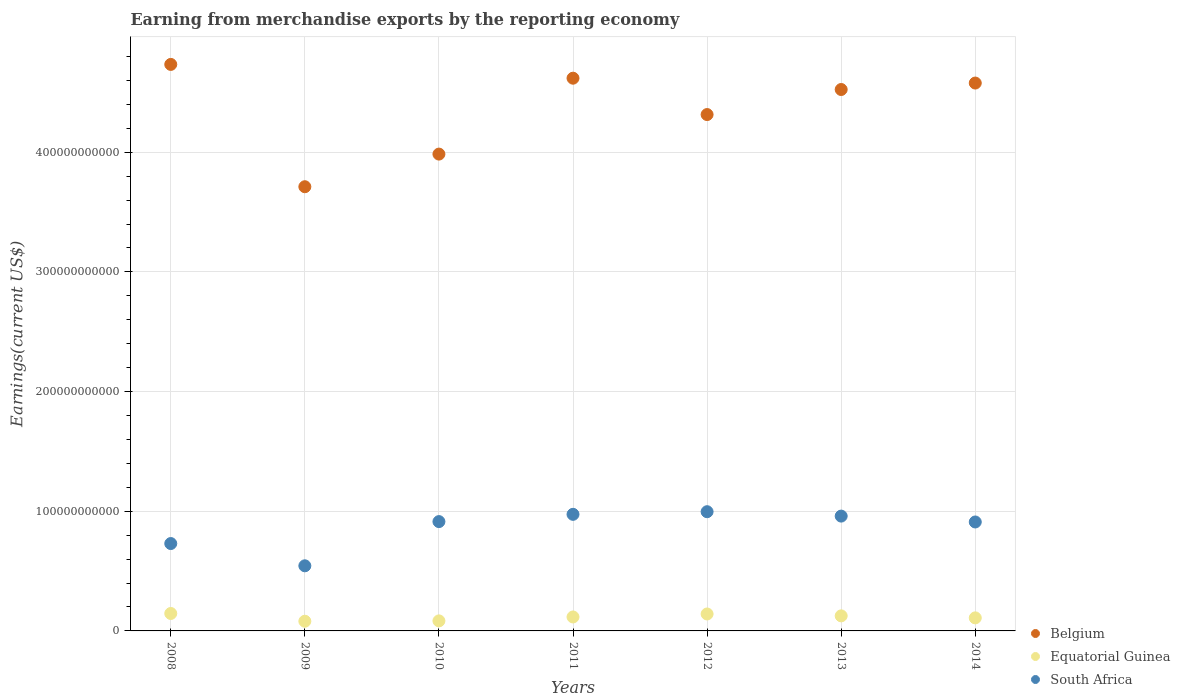How many different coloured dotlines are there?
Keep it short and to the point. 3. Is the number of dotlines equal to the number of legend labels?
Make the answer very short. Yes. What is the amount earned from merchandise exports in South Africa in 2013?
Your response must be concise. 9.59e+1. Across all years, what is the maximum amount earned from merchandise exports in Belgium?
Your answer should be very brief. 4.73e+11. Across all years, what is the minimum amount earned from merchandise exports in Equatorial Guinea?
Your answer should be compact. 8.09e+09. What is the total amount earned from merchandise exports in South Africa in the graph?
Give a very brief answer. 6.03e+11. What is the difference between the amount earned from merchandise exports in Belgium in 2008 and that in 2013?
Your answer should be very brief. 2.10e+1. What is the difference between the amount earned from merchandise exports in South Africa in 2011 and the amount earned from merchandise exports in Equatorial Guinea in 2012?
Ensure brevity in your answer.  8.33e+1. What is the average amount earned from merchandise exports in Belgium per year?
Give a very brief answer. 4.35e+11. In the year 2008, what is the difference between the amount earned from merchandise exports in South Africa and amount earned from merchandise exports in Equatorial Guinea?
Offer a very short reply. 5.84e+1. What is the ratio of the amount earned from merchandise exports in Belgium in 2009 to that in 2013?
Provide a succinct answer. 0.82. What is the difference between the highest and the second highest amount earned from merchandise exports in Equatorial Guinea?
Your answer should be compact. 4.06e+08. What is the difference between the highest and the lowest amount earned from merchandise exports in Equatorial Guinea?
Your answer should be compact. 6.48e+09. Is the sum of the amount earned from merchandise exports in Equatorial Guinea in 2009 and 2014 greater than the maximum amount earned from merchandise exports in South Africa across all years?
Your answer should be compact. No. Is it the case that in every year, the sum of the amount earned from merchandise exports in Equatorial Guinea and amount earned from merchandise exports in Belgium  is greater than the amount earned from merchandise exports in South Africa?
Give a very brief answer. Yes. Does the amount earned from merchandise exports in South Africa monotonically increase over the years?
Provide a succinct answer. No. Is the amount earned from merchandise exports in Equatorial Guinea strictly greater than the amount earned from merchandise exports in Belgium over the years?
Your answer should be compact. No. Is the amount earned from merchandise exports in Equatorial Guinea strictly less than the amount earned from merchandise exports in Belgium over the years?
Make the answer very short. Yes. How many years are there in the graph?
Your response must be concise. 7. What is the difference between two consecutive major ticks on the Y-axis?
Keep it short and to the point. 1.00e+11. Does the graph contain grids?
Keep it short and to the point. Yes. How are the legend labels stacked?
Your answer should be compact. Vertical. What is the title of the graph?
Your response must be concise. Earning from merchandise exports by the reporting economy. Does "Zimbabwe" appear as one of the legend labels in the graph?
Provide a succinct answer. No. What is the label or title of the Y-axis?
Offer a very short reply. Earnings(current US$). What is the Earnings(current US$) in Belgium in 2008?
Provide a succinct answer. 4.73e+11. What is the Earnings(current US$) in Equatorial Guinea in 2008?
Provide a short and direct response. 1.46e+1. What is the Earnings(current US$) in South Africa in 2008?
Keep it short and to the point. 7.30e+1. What is the Earnings(current US$) in Belgium in 2009?
Keep it short and to the point. 3.71e+11. What is the Earnings(current US$) in Equatorial Guinea in 2009?
Keep it short and to the point. 8.09e+09. What is the Earnings(current US$) in South Africa in 2009?
Your response must be concise. 5.44e+1. What is the Earnings(current US$) in Belgium in 2010?
Your answer should be compact. 3.98e+11. What is the Earnings(current US$) of Equatorial Guinea in 2010?
Keep it short and to the point. 8.39e+09. What is the Earnings(current US$) in South Africa in 2010?
Ensure brevity in your answer.  9.13e+1. What is the Earnings(current US$) in Belgium in 2011?
Ensure brevity in your answer.  4.62e+11. What is the Earnings(current US$) in Equatorial Guinea in 2011?
Your answer should be very brief. 1.17e+1. What is the Earnings(current US$) of South Africa in 2011?
Make the answer very short. 9.74e+1. What is the Earnings(current US$) of Belgium in 2012?
Offer a terse response. 4.31e+11. What is the Earnings(current US$) of Equatorial Guinea in 2012?
Ensure brevity in your answer.  1.42e+1. What is the Earnings(current US$) of South Africa in 2012?
Offer a very short reply. 9.96e+1. What is the Earnings(current US$) in Belgium in 2013?
Your answer should be very brief. 4.52e+11. What is the Earnings(current US$) in Equatorial Guinea in 2013?
Offer a terse response. 1.26e+1. What is the Earnings(current US$) in South Africa in 2013?
Give a very brief answer. 9.59e+1. What is the Earnings(current US$) of Belgium in 2014?
Give a very brief answer. 4.58e+11. What is the Earnings(current US$) of Equatorial Guinea in 2014?
Offer a terse response. 1.09e+1. What is the Earnings(current US$) of South Africa in 2014?
Offer a very short reply. 9.10e+1. Across all years, what is the maximum Earnings(current US$) of Belgium?
Keep it short and to the point. 4.73e+11. Across all years, what is the maximum Earnings(current US$) in Equatorial Guinea?
Offer a very short reply. 1.46e+1. Across all years, what is the maximum Earnings(current US$) of South Africa?
Keep it short and to the point. 9.96e+1. Across all years, what is the minimum Earnings(current US$) of Belgium?
Provide a succinct answer. 3.71e+11. Across all years, what is the minimum Earnings(current US$) in Equatorial Guinea?
Provide a succinct answer. 8.09e+09. Across all years, what is the minimum Earnings(current US$) in South Africa?
Offer a very short reply. 5.44e+1. What is the total Earnings(current US$) of Belgium in the graph?
Provide a succinct answer. 3.05e+12. What is the total Earnings(current US$) of Equatorial Guinea in the graph?
Give a very brief answer. 8.04e+1. What is the total Earnings(current US$) of South Africa in the graph?
Your answer should be very brief. 6.03e+11. What is the difference between the Earnings(current US$) in Belgium in 2008 and that in 2009?
Provide a succinct answer. 1.02e+11. What is the difference between the Earnings(current US$) of Equatorial Guinea in 2008 and that in 2009?
Provide a succinct answer. 6.48e+09. What is the difference between the Earnings(current US$) of South Africa in 2008 and that in 2009?
Your answer should be compact. 1.86e+1. What is the difference between the Earnings(current US$) of Belgium in 2008 and that in 2010?
Make the answer very short. 7.49e+1. What is the difference between the Earnings(current US$) in Equatorial Guinea in 2008 and that in 2010?
Provide a succinct answer. 6.17e+09. What is the difference between the Earnings(current US$) of South Africa in 2008 and that in 2010?
Keep it short and to the point. -1.83e+1. What is the difference between the Earnings(current US$) of Belgium in 2008 and that in 2011?
Provide a succinct answer. 1.15e+1. What is the difference between the Earnings(current US$) in Equatorial Guinea in 2008 and that in 2011?
Make the answer very short. 2.90e+09. What is the difference between the Earnings(current US$) in South Africa in 2008 and that in 2011?
Ensure brevity in your answer.  -2.44e+1. What is the difference between the Earnings(current US$) of Belgium in 2008 and that in 2012?
Offer a terse response. 4.19e+1. What is the difference between the Earnings(current US$) of Equatorial Guinea in 2008 and that in 2012?
Offer a very short reply. 4.06e+08. What is the difference between the Earnings(current US$) in South Africa in 2008 and that in 2012?
Offer a very short reply. -2.66e+1. What is the difference between the Earnings(current US$) in Belgium in 2008 and that in 2013?
Provide a succinct answer. 2.10e+1. What is the difference between the Earnings(current US$) in Equatorial Guinea in 2008 and that in 2013?
Your answer should be very brief. 1.99e+09. What is the difference between the Earnings(current US$) in South Africa in 2008 and that in 2013?
Provide a short and direct response. -2.29e+1. What is the difference between the Earnings(current US$) in Belgium in 2008 and that in 2014?
Give a very brief answer. 1.56e+1. What is the difference between the Earnings(current US$) of Equatorial Guinea in 2008 and that in 2014?
Give a very brief answer. 3.66e+09. What is the difference between the Earnings(current US$) in South Africa in 2008 and that in 2014?
Keep it short and to the point. -1.80e+1. What is the difference between the Earnings(current US$) in Belgium in 2009 and that in 2010?
Give a very brief answer. -2.73e+1. What is the difference between the Earnings(current US$) in Equatorial Guinea in 2009 and that in 2010?
Give a very brief answer. -3.05e+08. What is the difference between the Earnings(current US$) in South Africa in 2009 and that in 2010?
Ensure brevity in your answer.  -3.69e+1. What is the difference between the Earnings(current US$) in Belgium in 2009 and that in 2011?
Make the answer very short. -9.07e+1. What is the difference between the Earnings(current US$) in Equatorial Guinea in 2009 and that in 2011?
Provide a short and direct response. -3.58e+09. What is the difference between the Earnings(current US$) of South Africa in 2009 and that in 2011?
Give a very brief answer. -4.30e+1. What is the difference between the Earnings(current US$) of Belgium in 2009 and that in 2012?
Your response must be concise. -6.03e+1. What is the difference between the Earnings(current US$) of Equatorial Guinea in 2009 and that in 2012?
Offer a very short reply. -6.07e+09. What is the difference between the Earnings(current US$) of South Africa in 2009 and that in 2012?
Offer a terse response. -4.52e+1. What is the difference between the Earnings(current US$) in Belgium in 2009 and that in 2013?
Give a very brief answer. -8.12e+1. What is the difference between the Earnings(current US$) in Equatorial Guinea in 2009 and that in 2013?
Keep it short and to the point. -4.49e+09. What is the difference between the Earnings(current US$) of South Africa in 2009 and that in 2013?
Offer a terse response. -4.15e+1. What is the difference between the Earnings(current US$) in Belgium in 2009 and that in 2014?
Make the answer very short. -8.66e+1. What is the difference between the Earnings(current US$) of Equatorial Guinea in 2009 and that in 2014?
Make the answer very short. -2.82e+09. What is the difference between the Earnings(current US$) of South Africa in 2009 and that in 2014?
Ensure brevity in your answer.  -3.66e+1. What is the difference between the Earnings(current US$) of Belgium in 2010 and that in 2011?
Make the answer very short. -6.34e+1. What is the difference between the Earnings(current US$) of Equatorial Guinea in 2010 and that in 2011?
Your answer should be very brief. -3.27e+09. What is the difference between the Earnings(current US$) in South Africa in 2010 and that in 2011?
Your answer should be compact. -6.07e+09. What is the difference between the Earnings(current US$) in Belgium in 2010 and that in 2012?
Ensure brevity in your answer.  -3.30e+1. What is the difference between the Earnings(current US$) of Equatorial Guinea in 2010 and that in 2012?
Ensure brevity in your answer.  -5.77e+09. What is the difference between the Earnings(current US$) in South Africa in 2010 and that in 2012?
Keep it short and to the point. -8.26e+09. What is the difference between the Earnings(current US$) of Belgium in 2010 and that in 2013?
Offer a terse response. -5.40e+1. What is the difference between the Earnings(current US$) of Equatorial Guinea in 2010 and that in 2013?
Your answer should be very brief. -4.19e+09. What is the difference between the Earnings(current US$) in South Africa in 2010 and that in 2013?
Provide a succinct answer. -4.59e+09. What is the difference between the Earnings(current US$) of Belgium in 2010 and that in 2014?
Provide a succinct answer. -5.94e+1. What is the difference between the Earnings(current US$) of Equatorial Guinea in 2010 and that in 2014?
Provide a succinct answer. -2.51e+09. What is the difference between the Earnings(current US$) in South Africa in 2010 and that in 2014?
Your answer should be compact. 3.21e+08. What is the difference between the Earnings(current US$) of Belgium in 2011 and that in 2012?
Provide a succinct answer. 3.04e+1. What is the difference between the Earnings(current US$) in Equatorial Guinea in 2011 and that in 2012?
Provide a succinct answer. -2.50e+09. What is the difference between the Earnings(current US$) in South Africa in 2011 and that in 2012?
Provide a short and direct response. -2.20e+09. What is the difference between the Earnings(current US$) of Belgium in 2011 and that in 2013?
Ensure brevity in your answer.  9.45e+09. What is the difference between the Earnings(current US$) in Equatorial Guinea in 2011 and that in 2013?
Provide a succinct answer. -9.15e+08. What is the difference between the Earnings(current US$) of South Africa in 2011 and that in 2013?
Keep it short and to the point. 1.48e+09. What is the difference between the Earnings(current US$) of Belgium in 2011 and that in 2014?
Your answer should be compact. 4.06e+09. What is the difference between the Earnings(current US$) in Equatorial Guinea in 2011 and that in 2014?
Your response must be concise. 7.57e+08. What is the difference between the Earnings(current US$) of South Africa in 2011 and that in 2014?
Your answer should be compact. 6.39e+09. What is the difference between the Earnings(current US$) of Belgium in 2012 and that in 2013?
Your response must be concise. -2.09e+1. What is the difference between the Earnings(current US$) in Equatorial Guinea in 2012 and that in 2013?
Provide a short and direct response. 1.58e+09. What is the difference between the Earnings(current US$) in South Africa in 2012 and that in 2013?
Make the answer very short. 3.67e+09. What is the difference between the Earnings(current US$) in Belgium in 2012 and that in 2014?
Your response must be concise. -2.63e+1. What is the difference between the Earnings(current US$) in Equatorial Guinea in 2012 and that in 2014?
Make the answer very short. 3.26e+09. What is the difference between the Earnings(current US$) of South Africa in 2012 and that in 2014?
Keep it short and to the point. 8.58e+09. What is the difference between the Earnings(current US$) in Belgium in 2013 and that in 2014?
Keep it short and to the point. -5.39e+09. What is the difference between the Earnings(current US$) in Equatorial Guinea in 2013 and that in 2014?
Make the answer very short. 1.67e+09. What is the difference between the Earnings(current US$) of South Africa in 2013 and that in 2014?
Your answer should be compact. 4.91e+09. What is the difference between the Earnings(current US$) of Belgium in 2008 and the Earnings(current US$) of Equatorial Guinea in 2009?
Ensure brevity in your answer.  4.65e+11. What is the difference between the Earnings(current US$) in Belgium in 2008 and the Earnings(current US$) in South Africa in 2009?
Make the answer very short. 4.19e+11. What is the difference between the Earnings(current US$) of Equatorial Guinea in 2008 and the Earnings(current US$) of South Africa in 2009?
Keep it short and to the point. -3.98e+1. What is the difference between the Earnings(current US$) of Belgium in 2008 and the Earnings(current US$) of Equatorial Guinea in 2010?
Provide a short and direct response. 4.65e+11. What is the difference between the Earnings(current US$) of Belgium in 2008 and the Earnings(current US$) of South Africa in 2010?
Your response must be concise. 3.82e+11. What is the difference between the Earnings(current US$) in Equatorial Guinea in 2008 and the Earnings(current US$) in South Africa in 2010?
Make the answer very short. -7.68e+1. What is the difference between the Earnings(current US$) of Belgium in 2008 and the Earnings(current US$) of Equatorial Guinea in 2011?
Ensure brevity in your answer.  4.62e+11. What is the difference between the Earnings(current US$) of Belgium in 2008 and the Earnings(current US$) of South Africa in 2011?
Offer a terse response. 3.76e+11. What is the difference between the Earnings(current US$) in Equatorial Guinea in 2008 and the Earnings(current US$) in South Africa in 2011?
Provide a short and direct response. -8.28e+1. What is the difference between the Earnings(current US$) of Belgium in 2008 and the Earnings(current US$) of Equatorial Guinea in 2012?
Offer a very short reply. 4.59e+11. What is the difference between the Earnings(current US$) of Belgium in 2008 and the Earnings(current US$) of South Africa in 2012?
Offer a terse response. 3.74e+11. What is the difference between the Earnings(current US$) in Equatorial Guinea in 2008 and the Earnings(current US$) in South Africa in 2012?
Offer a very short reply. -8.50e+1. What is the difference between the Earnings(current US$) in Belgium in 2008 and the Earnings(current US$) in Equatorial Guinea in 2013?
Offer a very short reply. 4.61e+11. What is the difference between the Earnings(current US$) of Belgium in 2008 and the Earnings(current US$) of South Africa in 2013?
Offer a very short reply. 3.77e+11. What is the difference between the Earnings(current US$) of Equatorial Guinea in 2008 and the Earnings(current US$) of South Africa in 2013?
Ensure brevity in your answer.  -8.14e+1. What is the difference between the Earnings(current US$) in Belgium in 2008 and the Earnings(current US$) in Equatorial Guinea in 2014?
Offer a terse response. 4.62e+11. What is the difference between the Earnings(current US$) in Belgium in 2008 and the Earnings(current US$) in South Africa in 2014?
Offer a terse response. 3.82e+11. What is the difference between the Earnings(current US$) in Equatorial Guinea in 2008 and the Earnings(current US$) in South Africa in 2014?
Provide a short and direct response. -7.65e+1. What is the difference between the Earnings(current US$) in Belgium in 2009 and the Earnings(current US$) in Equatorial Guinea in 2010?
Your answer should be very brief. 3.63e+11. What is the difference between the Earnings(current US$) in Belgium in 2009 and the Earnings(current US$) in South Africa in 2010?
Provide a short and direct response. 2.80e+11. What is the difference between the Earnings(current US$) in Equatorial Guinea in 2009 and the Earnings(current US$) in South Africa in 2010?
Provide a short and direct response. -8.33e+1. What is the difference between the Earnings(current US$) in Belgium in 2009 and the Earnings(current US$) in Equatorial Guinea in 2011?
Provide a succinct answer. 3.59e+11. What is the difference between the Earnings(current US$) in Belgium in 2009 and the Earnings(current US$) in South Africa in 2011?
Make the answer very short. 2.74e+11. What is the difference between the Earnings(current US$) of Equatorial Guinea in 2009 and the Earnings(current US$) of South Africa in 2011?
Offer a terse response. -8.93e+1. What is the difference between the Earnings(current US$) in Belgium in 2009 and the Earnings(current US$) in Equatorial Guinea in 2012?
Your answer should be compact. 3.57e+11. What is the difference between the Earnings(current US$) of Belgium in 2009 and the Earnings(current US$) of South Africa in 2012?
Provide a succinct answer. 2.72e+11. What is the difference between the Earnings(current US$) in Equatorial Guinea in 2009 and the Earnings(current US$) in South Africa in 2012?
Keep it short and to the point. -9.15e+1. What is the difference between the Earnings(current US$) of Belgium in 2009 and the Earnings(current US$) of Equatorial Guinea in 2013?
Make the answer very short. 3.59e+11. What is the difference between the Earnings(current US$) in Belgium in 2009 and the Earnings(current US$) in South Africa in 2013?
Keep it short and to the point. 2.75e+11. What is the difference between the Earnings(current US$) of Equatorial Guinea in 2009 and the Earnings(current US$) of South Africa in 2013?
Your answer should be very brief. -8.78e+1. What is the difference between the Earnings(current US$) of Belgium in 2009 and the Earnings(current US$) of Equatorial Guinea in 2014?
Provide a succinct answer. 3.60e+11. What is the difference between the Earnings(current US$) of Belgium in 2009 and the Earnings(current US$) of South Africa in 2014?
Offer a very short reply. 2.80e+11. What is the difference between the Earnings(current US$) of Equatorial Guinea in 2009 and the Earnings(current US$) of South Africa in 2014?
Offer a very short reply. -8.29e+1. What is the difference between the Earnings(current US$) in Belgium in 2010 and the Earnings(current US$) in Equatorial Guinea in 2011?
Offer a very short reply. 3.87e+11. What is the difference between the Earnings(current US$) in Belgium in 2010 and the Earnings(current US$) in South Africa in 2011?
Your response must be concise. 3.01e+11. What is the difference between the Earnings(current US$) of Equatorial Guinea in 2010 and the Earnings(current US$) of South Africa in 2011?
Your answer should be compact. -8.90e+1. What is the difference between the Earnings(current US$) in Belgium in 2010 and the Earnings(current US$) in Equatorial Guinea in 2012?
Keep it short and to the point. 3.84e+11. What is the difference between the Earnings(current US$) in Belgium in 2010 and the Earnings(current US$) in South Africa in 2012?
Provide a succinct answer. 2.99e+11. What is the difference between the Earnings(current US$) of Equatorial Guinea in 2010 and the Earnings(current US$) of South Africa in 2012?
Your response must be concise. -9.12e+1. What is the difference between the Earnings(current US$) of Belgium in 2010 and the Earnings(current US$) of Equatorial Guinea in 2013?
Give a very brief answer. 3.86e+11. What is the difference between the Earnings(current US$) in Belgium in 2010 and the Earnings(current US$) in South Africa in 2013?
Make the answer very short. 3.02e+11. What is the difference between the Earnings(current US$) of Equatorial Guinea in 2010 and the Earnings(current US$) of South Africa in 2013?
Give a very brief answer. -8.75e+1. What is the difference between the Earnings(current US$) in Belgium in 2010 and the Earnings(current US$) in Equatorial Guinea in 2014?
Keep it short and to the point. 3.88e+11. What is the difference between the Earnings(current US$) in Belgium in 2010 and the Earnings(current US$) in South Africa in 2014?
Make the answer very short. 3.07e+11. What is the difference between the Earnings(current US$) in Equatorial Guinea in 2010 and the Earnings(current US$) in South Africa in 2014?
Your answer should be compact. -8.26e+1. What is the difference between the Earnings(current US$) of Belgium in 2011 and the Earnings(current US$) of Equatorial Guinea in 2012?
Offer a terse response. 4.48e+11. What is the difference between the Earnings(current US$) of Belgium in 2011 and the Earnings(current US$) of South Africa in 2012?
Give a very brief answer. 3.62e+11. What is the difference between the Earnings(current US$) of Equatorial Guinea in 2011 and the Earnings(current US$) of South Africa in 2012?
Your response must be concise. -8.79e+1. What is the difference between the Earnings(current US$) in Belgium in 2011 and the Earnings(current US$) in Equatorial Guinea in 2013?
Your answer should be compact. 4.49e+11. What is the difference between the Earnings(current US$) of Belgium in 2011 and the Earnings(current US$) of South Africa in 2013?
Your answer should be very brief. 3.66e+11. What is the difference between the Earnings(current US$) in Equatorial Guinea in 2011 and the Earnings(current US$) in South Africa in 2013?
Offer a very short reply. -8.43e+1. What is the difference between the Earnings(current US$) of Belgium in 2011 and the Earnings(current US$) of Equatorial Guinea in 2014?
Your answer should be very brief. 4.51e+11. What is the difference between the Earnings(current US$) in Belgium in 2011 and the Earnings(current US$) in South Africa in 2014?
Keep it short and to the point. 3.71e+11. What is the difference between the Earnings(current US$) in Equatorial Guinea in 2011 and the Earnings(current US$) in South Africa in 2014?
Make the answer very short. -7.94e+1. What is the difference between the Earnings(current US$) of Belgium in 2012 and the Earnings(current US$) of Equatorial Guinea in 2013?
Your answer should be compact. 4.19e+11. What is the difference between the Earnings(current US$) in Belgium in 2012 and the Earnings(current US$) in South Africa in 2013?
Your answer should be compact. 3.36e+11. What is the difference between the Earnings(current US$) in Equatorial Guinea in 2012 and the Earnings(current US$) in South Africa in 2013?
Provide a short and direct response. -8.18e+1. What is the difference between the Earnings(current US$) of Belgium in 2012 and the Earnings(current US$) of Equatorial Guinea in 2014?
Your answer should be compact. 4.21e+11. What is the difference between the Earnings(current US$) in Belgium in 2012 and the Earnings(current US$) in South Africa in 2014?
Offer a terse response. 3.40e+11. What is the difference between the Earnings(current US$) in Equatorial Guinea in 2012 and the Earnings(current US$) in South Africa in 2014?
Make the answer very short. -7.69e+1. What is the difference between the Earnings(current US$) of Belgium in 2013 and the Earnings(current US$) of Equatorial Guinea in 2014?
Make the answer very short. 4.41e+11. What is the difference between the Earnings(current US$) in Belgium in 2013 and the Earnings(current US$) in South Africa in 2014?
Keep it short and to the point. 3.61e+11. What is the difference between the Earnings(current US$) of Equatorial Guinea in 2013 and the Earnings(current US$) of South Africa in 2014?
Provide a short and direct response. -7.84e+1. What is the average Earnings(current US$) of Belgium per year?
Ensure brevity in your answer.  4.35e+11. What is the average Earnings(current US$) in Equatorial Guinea per year?
Your answer should be compact. 1.15e+1. What is the average Earnings(current US$) of South Africa per year?
Offer a terse response. 8.61e+1. In the year 2008, what is the difference between the Earnings(current US$) of Belgium and Earnings(current US$) of Equatorial Guinea?
Provide a short and direct response. 4.59e+11. In the year 2008, what is the difference between the Earnings(current US$) in Belgium and Earnings(current US$) in South Africa?
Make the answer very short. 4.00e+11. In the year 2008, what is the difference between the Earnings(current US$) in Equatorial Guinea and Earnings(current US$) in South Africa?
Provide a succinct answer. -5.84e+1. In the year 2009, what is the difference between the Earnings(current US$) in Belgium and Earnings(current US$) in Equatorial Guinea?
Give a very brief answer. 3.63e+11. In the year 2009, what is the difference between the Earnings(current US$) in Belgium and Earnings(current US$) in South Africa?
Offer a terse response. 3.17e+11. In the year 2009, what is the difference between the Earnings(current US$) of Equatorial Guinea and Earnings(current US$) of South Africa?
Your answer should be compact. -4.63e+1. In the year 2010, what is the difference between the Earnings(current US$) of Belgium and Earnings(current US$) of Equatorial Guinea?
Offer a terse response. 3.90e+11. In the year 2010, what is the difference between the Earnings(current US$) of Belgium and Earnings(current US$) of South Africa?
Give a very brief answer. 3.07e+11. In the year 2010, what is the difference between the Earnings(current US$) of Equatorial Guinea and Earnings(current US$) of South Africa?
Keep it short and to the point. -8.30e+1. In the year 2011, what is the difference between the Earnings(current US$) of Belgium and Earnings(current US$) of Equatorial Guinea?
Provide a short and direct response. 4.50e+11. In the year 2011, what is the difference between the Earnings(current US$) of Belgium and Earnings(current US$) of South Africa?
Give a very brief answer. 3.64e+11. In the year 2011, what is the difference between the Earnings(current US$) of Equatorial Guinea and Earnings(current US$) of South Africa?
Offer a terse response. -8.58e+1. In the year 2012, what is the difference between the Earnings(current US$) in Belgium and Earnings(current US$) in Equatorial Guinea?
Provide a succinct answer. 4.17e+11. In the year 2012, what is the difference between the Earnings(current US$) of Belgium and Earnings(current US$) of South Africa?
Give a very brief answer. 3.32e+11. In the year 2012, what is the difference between the Earnings(current US$) of Equatorial Guinea and Earnings(current US$) of South Africa?
Your answer should be very brief. -8.54e+1. In the year 2013, what is the difference between the Earnings(current US$) of Belgium and Earnings(current US$) of Equatorial Guinea?
Keep it short and to the point. 4.40e+11. In the year 2013, what is the difference between the Earnings(current US$) of Belgium and Earnings(current US$) of South Africa?
Your answer should be very brief. 3.56e+11. In the year 2013, what is the difference between the Earnings(current US$) in Equatorial Guinea and Earnings(current US$) in South Africa?
Offer a terse response. -8.34e+1. In the year 2014, what is the difference between the Earnings(current US$) in Belgium and Earnings(current US$) in Equatorial Guinea?
Give a very brief answer. 4.47e+11. In the year 2014, what is the difference between the Earnings(current US$) in Belgium and Earnings(current US$) in South Africa?
Provide a succinct answer. 3.67e+11. In the year 2014, what is the difference between the Earnings(current US$) in Equatorial Guinea and Earnings(current US$) in South Africa?
Provide a short and direct response. -8.01e+1. What is the ratio of the Earnings(current US$) of Belgium in 2008 to that in 2009?
Keep it short and to the point. 1.28. What is the ratio of the Earnings(current US$) in Equatorial Guinea in 2008 to that in 2009?
Offer a very short reply. 1.8. What is the ratio of the Earnings(current US$) in South Africa in 2008 to that in 2009?
Offer a very short reply. 1.34. What is the ratio of the Earnings(current US$) of Belgium in 2008 to that in 2010?
Provide a short and direct response. 1.19. What is the ratio of the Earnings(current US$) in Equatorial Guinea in 2008 to that in 2010?
Keep it short and to the point. 1.74. What is the ratio of the Earnings(current US$) of South Africa in 2008 to that in 2010?
Your answer should be very brief. 0.8. What is the ratio of the Earnings(current US$) of Belgium in 2008 to that in 2011?
Your answer should be compact. 1.02. What is the ratio of the Earnings(current US$) in Equatorial Guinea in 2008 to that in 2011?
Your answer should be compact. 1.25. What is the ratio of the Earnings(current US$) of South Africa in 2008 to that in 2011?
Make the answer very short. 0.75. What is the ratio of the Earnings(current US$) in Belgium in 2008 to that in 2012?
Offer a terse response. 1.1. What is the ratio of the Earnings(current US$) of Equatorial Guinea in 2008 to that in 2012?
Your answer should be very brief. 1.03. What is the ratio of the Earnings(current US$) of South Africa in 2008 to that in 2012?
Make the answer very short. 0.73. What is the ratio of the Earnings(current US$) of Belgium in 2008 to that in 2013?
Keep it short and to the point. 1.05. What is the ratio of the Earnings(current US$) in Equatorial Guinea in 2008 to that in 2013?
Provide a short and direct response. 1.16. What is the ratio of the Earnings(current US$) of South Africa in 2008 to that in 2013?
Ensure brevity in your answer.  0.76. What is the ratio of the Earnings(current US$) in Belgium in 2008 to that in 2014?
Your answer should be compact. 1.03. What is the ratio of the Earnings(current US$) in Equatorial Guinea in 2008 to that in 2014?
Offer a terse response. 1.34. What is the ratio of the Earnings(current US$) in South Africa in 2008 to that in 2014?
Offer a terse response. 0.8. What is the ratio of the Earnings(current US$) in Belgium in 2009 to that in 2010?
Offer a terse response. 0.93. What is the ratio of the Earnings(current US$) of Equatorial Guinea in 2009 to that in 2010?
Make the answer very short. 0.96. What is the ratio of the Earnings(current US$) in South Africa in 2009 to that in 2010?
Offer a very short reply. 0.6. What is the ratio of the Earnings(current US$) in Belgium in 2009 to that in 2011?
Your answer should be very brief. 0.8. What is the ratio of the Earnings(current US$) in Equatorial Guinea in 2009 to that in 2011?
Your response must be concise. 0.69. What is the ratio of the Earnings(current US$) of South Africa in 2009 to that in 2011?
Make the answer very short. 0.56. What is the ratio of the Earnings(current US$) in Belgium in 2009 to that in 2012?
Your answer should be very brief. 0.86. What is the ratio of the Earnings(current US$) in Equatorial Guinea in 2009 to that in 2012?
Make the answer very short. 0.57. What is the ratio of the Earnings(current US$) of South Africa in 2009 to that in 2012?
Your response must be concise. 0.55. What is the ratio of the Earnings(current US$) in Belgium in 2009 to that in 2013?
Make the answer very short. 0.82. What is the ratio of the Earnings(current US$) in Equatorial Guinea in 2009 to that in 2013?
Provide a succinct answer. 0.64. What is the ratio of the Earnings(current US$) in South Africa in 2009 to that in 2013?
Your answer should be compact. 0.57. What is the ratio of the Earnings(current US$) in Belgium in 2009 to that in 2014?
Provide a short and direct response. 0.81. What is the ratio of the Earnings(current US$) in Equatorial Guinea in 2009 to that in 2014?
Your answer should be very brief. 0.74. What is the ratio of the Earnings(current US$) of South Africa in 2009 to that in 2014?
Offer a very short reply. 0.6. What is the ratio of the Earnings(current US$) of Belgium in 2010 to that in 2011?
Ensure brevity in your answer.  0.86. What is the ratio of the Earnings(current US$) of Equatorial Guinea in 2010 to that in 2011?
Provide a succinct answer. 0.72. What is the ratio of the Earnings(current US$) of South Africa in 2010 to that in 2011?
Your answer should be very brief. 0.94. What is the ratio of the Earnings(current US$) in Belgium in 2010 to that in 2012?
Your response must be concise. 0.92. What is the ratio of the Earnings(current US$) of Equatorial Guinea in 2010 to that in 2012?
Give a very brief answer. 0.59. What is the ratio of the Earnings(current US$) in South Africa in 2010 to that in 2012?
Your response must be concise. 0.92. What is the ratio of the Earnings(current US$) of Belgium in 2010 to that in 2013?
Your answer should be compact. 0.88. What is the ratio of the Earnings(current US$) in Equatorial Guinea in 2010 to that in 2013?
Offer a terse response. 0.67. What is the ratio of the Earnings(current US$) in South Africa in 2010 to that in 2013?
Ensure brevity in your answer.  0.95. What is the ratio of the Earnings(current US$) in Belgium in 2010 to that in 2014?
Give a very brief answer. 0.87. What is the ratio of the Earnings(current US$) in Equatorial Guinea in 2010 to that in 2014?
Ensure brevity in your answer.  0.77. What is the ratio of the Earnings(current US$) in South Africa in 2010 to that in 2014?
Make the answer very short. 1. What is the ratio of the Earnings(current US$) in Belgium in 2011 to that in 2012?
Make the answer very short. 1.07. What is the ratio of the Earnings(current US$) in Equatorial Guinea in 2011 to that in 2012?
Your answer should be compact. 0.82. What is the ratio of the Earnings(current US$) in Belgium in 2011 to that in 2013?
Your response must be concise. 1.02. What is the ratio of the Earnings(current US$) of Equatorial Guinea in 2011 to that in 2013?
Offer a very short reply. 0.93. What is the ratio of the Earnings(current US$) of South Africa in 2011 to that in 2013?
Your answer should be very brief. 1.02. What is the ratio of the Earnings(current US$) in Belgium in 2011 to that in 2014?
Ensure brevity in your answer.  1.01. What is the ratio of the Earnings(current US$) of Equatorial Guinea in 2011 to that in 2014?
Ensure brevity in your answer.  1.07. What is the ratio of the Earnings(current US$) of South Africa in 2011 to that in 2014?
Your answer should be compact. 1.07. What is the ratio of the Earnings(current US$) of Belgium in 2012 to that in 2013?
Provide a short and direct response. 0.95. What is the ratio of the Earnings(current US$) in Equatorial Guinea in 2012 to that in 2013?
Provide a succinct answer. 1.13. What is the ratio of the Earnings(current US$) in South Africa in 2012 to that in 2013?
Offer a very short reply. 1.04. What is the ratio of the Earnings(current US$) of Belgium in 2012 to that in 2014?
Offer a terse response. 0.94. What is the ratio of the Earnings(current US$) of Equatorial Guinea in 2012 to that in 2014?
Ensure brevity in your answer.  1.3. What is the ratio of the Earnings(current US$) of South Africa in 2012 to that in 2014?
Ensure brevity in your answer.  1.09. What is the ratio of the Earnings(current US$) of Equatorial Guinea in 2013 to that in 2014?
Offer a very short reply. 1.15. What is the ratio of the Earnings(current US$) in South Africa in 2013 to that in 2014?
Offer a very short reply. 1.05. What is the difference between the highest and the second highest Earnings(current US$) in Belgium?
Ensure brevity in your answer.  1.15e+1. What is the difference between the highest and the second highest Earnings(current US$) in Equatorial Guinea?
Your answer should be very brief. 4.06e+08. What is the difference between the highest and the second highest Earnings(current US$) of South Africa?
Your response must be concise. 2.20e+09. What is the difference between the highest and the lowest Earnings(current US$) of Belgium?
Offer a terse response. 1.02e+11. What is the difference between the highest and the lowest Earnings(current US$) of Equatorial Guinea?
Offer a very short reply. 6.48e+09. What is the difference between the highest and the lowest Earnings(current US$) in South Africa?
Your response must be concise. 4.52e+1. 